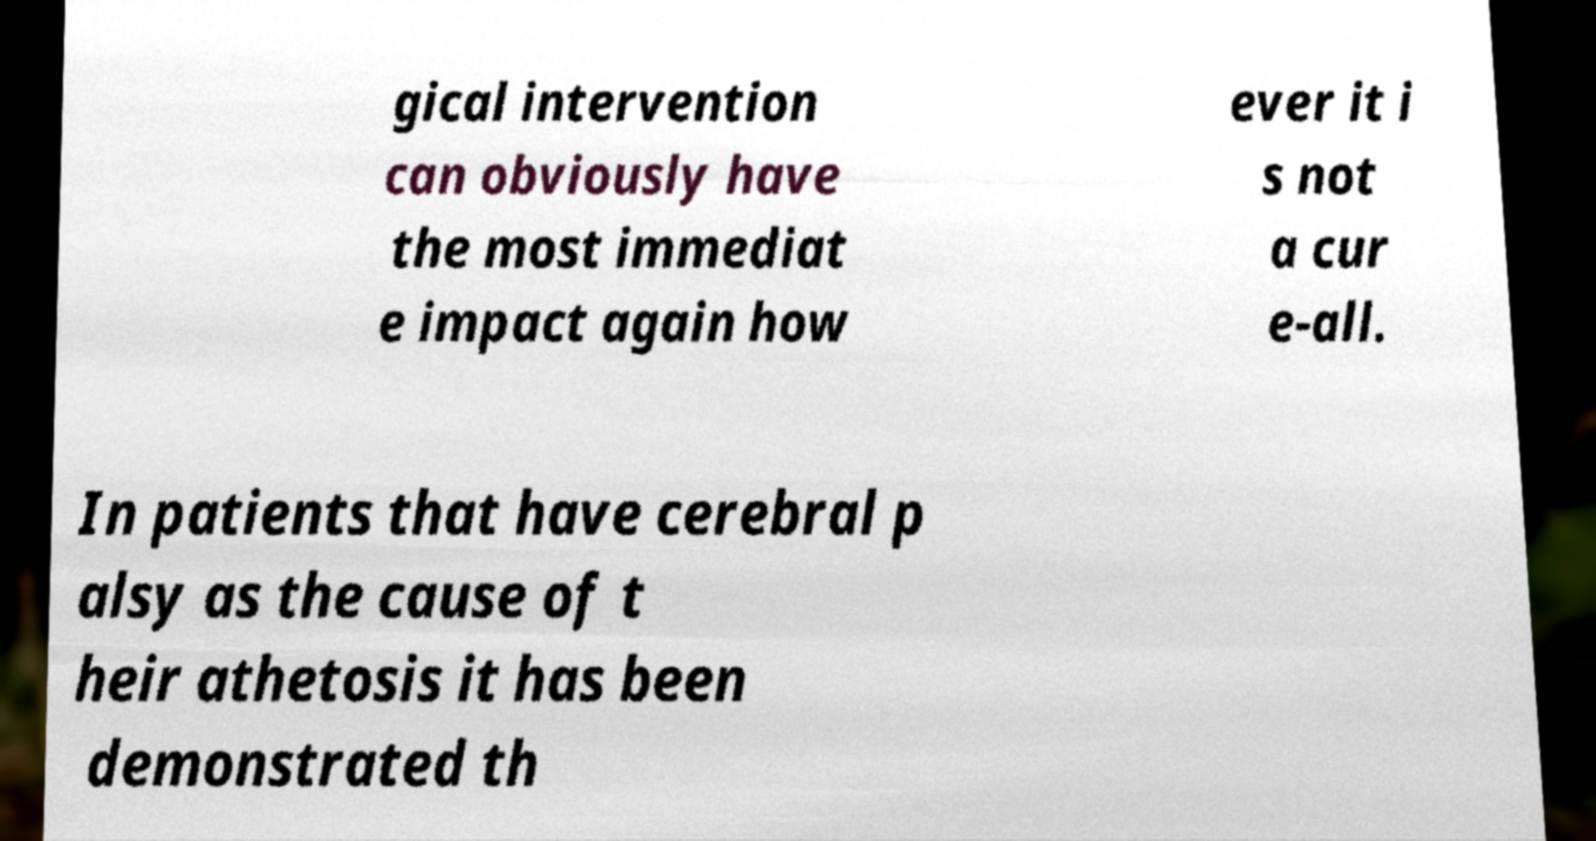Can you accurately transcribe the text from the provided image for me? gical intervention can obviously have the most immediat e impact again how ever it i s not a cur e-all. In patients that have cerebral p alsy as the cause of t heir athetosis it has been demonstrated th 